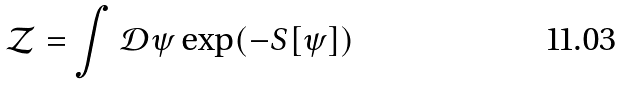<formula> <loc_0><loc_0><loc_500><loc_500>\mathcal { Z } = \int \mathcal { D } \psi \exp ( - S [ \psi ] )</formula> 